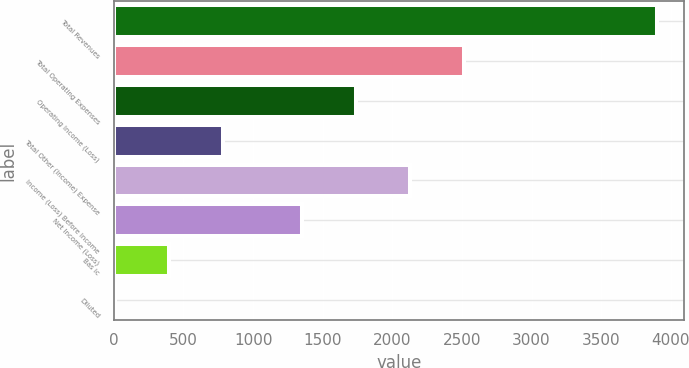Convert chart to OTSL. <chart><loc_0><loc_0><loc_500><loc_500><bar_chart><fcel>Total Revenues<fcel>Total Operating Expenses<fcel>Operating Income (Loss)<fcel>Total Other (Income) Expense<fcel>Income (Loss) Before Income<fcel>Net Income (Loss)<fcel>Bas ic<fcel>Diluted<nl><fcel>3901<fcel>2518.02<fcel>1739.34<fcel>786.26<fcel>2128.68<fcel>1350<fcel>396.92<fcel>7.58<nl></chart> 